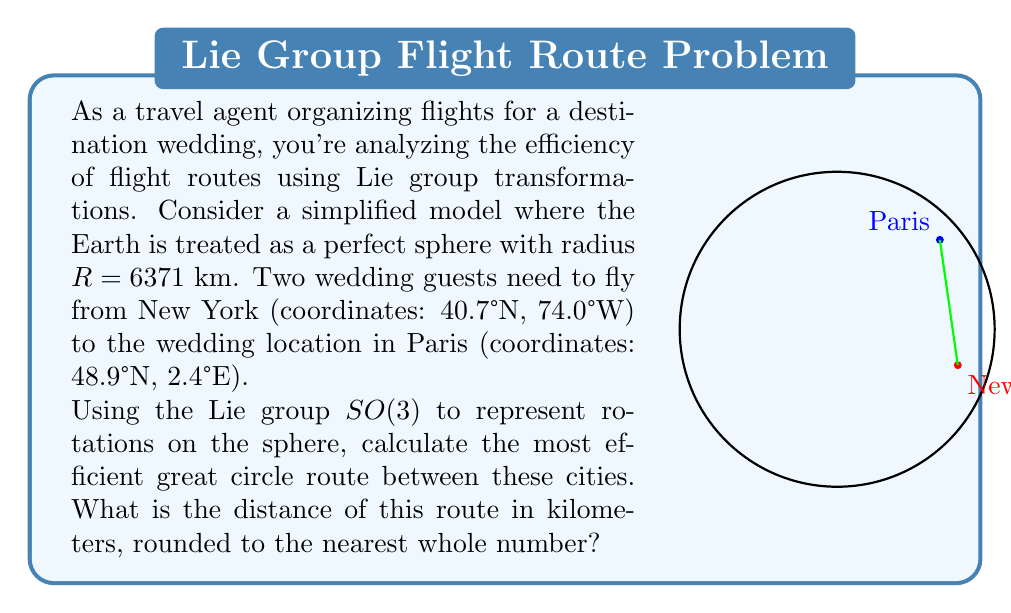What is the answer to this math problem? To solve this problem using Lie group transformations, we'll follow these steps:

1) First, we need to convert the coordinates to radians:
   New York: (40.7°N, 74.0°W) → ($\frac{40.7\pi}{180}$, $-\frac{74.0\pi}{180}$)
   Paris: (48.9°N, 2.4°E) → ($\frac{48.9\pi}{180}$, $\frac{2.4\pi}{180}$)

2) Now, we'll represent these points as unit vectors in $\mathbb{R}^3$:
   $$\vec{v}_1 = \begin{pmatrix}
   \cos(40.7\pi/180)\cos(-74.0\pi/180) \\
   \cos(40.7\pi/180)\sin(-74.0\pi/180) \\
   \sin(40.7\pi/180)
   \end{pmatrix}$$

   $$\vec{v}_2 = \begin{pmatrix}
   \cos(48.9\pi/180)\cos(2.4\pi/180) \\
   \cos(48.9\pi/180)\sin(2.4\pi/180) \\
   \sin(48.9\pi/180)
   \end{pmatrix}$$

3) The angle $\theta$ between these vectors is given by their dot product:
   $$\cos(\theta) = \vec{v}_1 \cdot \vec{v}_2$$

4) Calculate this dot product:
   $$\cos(\theta) = 0.766 \times 0.652 + (-0.228) \times 0.0274 + 0.601 \times 0.753 = 0.9508$$

5) Take the arccos to find $\theta$:
   $$\theta = \arccos(0.9508) = 0.3133 \text{ radians}$$

6) The great circle distance is then:
   $$d = R\theta = 6371 \times 0.3133 = 1996.14 \text{ km}$$

7) Rounding to the nearest whole number:
   $$d \approx 1996 \text{ km}$$

This method uses the Lie group $SO(3)$ implicitly, as the rotations that take one point to another on the sphere are elements of this group. The most efficient route is the one that requires the smallest rotation, which is the great circle route we've calculated.
Answer: 1996 km 